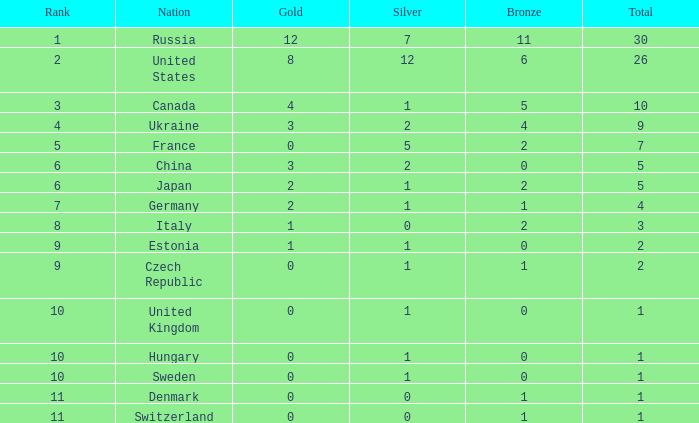Would you be able to parse every entry in this table? {'header': ['Rank', 'Nation', 'Gold', 'Silver', 'Bronze', 'Total'], 'rows': [['1', 'Russia', '12', '7', '11', '30'], ['2', 'United States', '8', '12', '6', '26'], ['3', 'Canada', '4', '1', '5', '10'], ['4', 'Ukraine', '3', '2', '4', '9'], ['5', 'France', '0', '5', '2', '7'], ['6', 'China', '3', '2', '0', '5'], ['6', 'Japan', '2', '1', '2', '5'], ['7', 'Germany', '2', '1', '1', '4'], ['8', 'Italy', '1', '0', '2', '3'], ['9', 'Estonia', '1', '1', '0', '2'], ['9', 'Czech Republic', '0', '1', '1', '2'], ['10', 'United Kingdom', '0', '1', '0', '1'], ['10', 'Hungary', '0', '1', '0', '1'], ['10', 'Sweden', '0', '1', '0', '1'], ['11', 'Denmark', '0', '0', '1', '1'], ['11', 'Switzerland', '0', '0', '1', '1']]} Which silver has a Gold smaller than 12, a Rank smaller than 5, and a Bronze of 5? 1.0. 